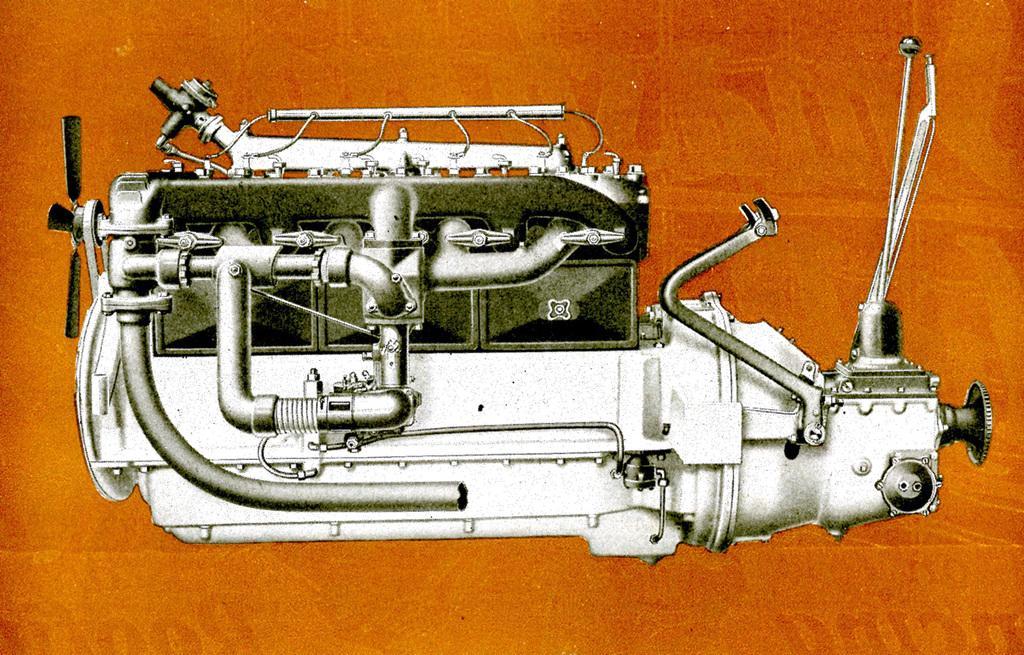Describe this image in one or two sentences. In the picture I can see an engine which is in silver color and the background is in orange color. 